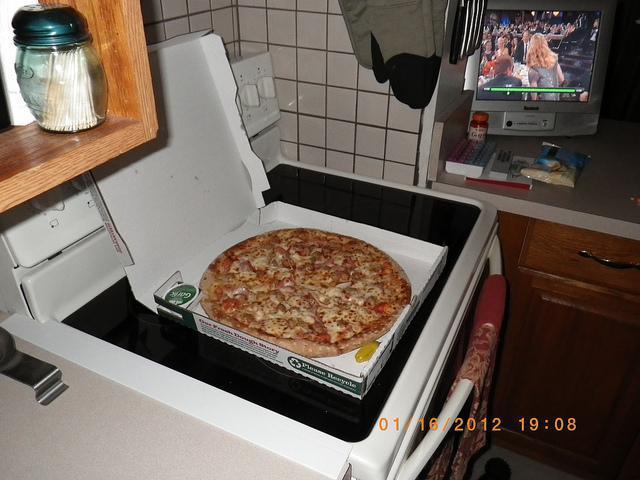How many pizzas?
Give a very brief answer. 1. How many pizzas are in the picture?
Give a very brief answer. 1. How many people are wearing skis in this image?
Give a very brief answer. 0. 